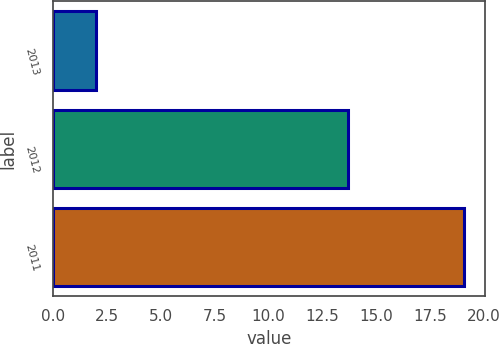Convert chart. <chart><loc_0><loc_0><loc_500><loc_500><bar_chart><fcel>2013<fcel>2012<fcel>2011<nl><fcel>2<fcel>13.7<fcel>19.1<nl></chart> 